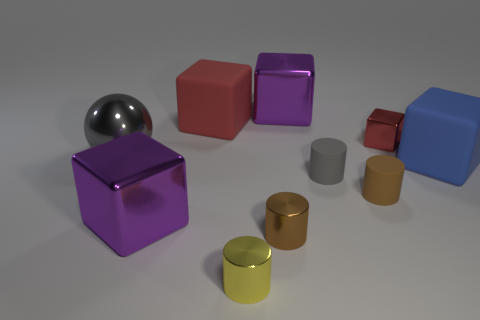Subtract all cyan cylinders. How many purple cubes are left? 2 Subtract all purple cubes. How many cubes are left? 3 Subtract 1 blocks. How many blocks are left? 4 Subtract all red blocks. How many blocks are left? 3 Subtract all spheres. How many objects are left? 9 Subtract all purple cubes. Subtract all gray cylinders. How many cubes are left? 3 Add 9 red rubber blocks. How many red rubber blocks are left? 10 Add 6 tiny cylinders. How many tiny cylinders exist? 10 Subtract 0 purple cylinders. How many objects are left? 10 Subtract all brown shiny things. Subtract all gray metal spheres. How many objects are left? 8 